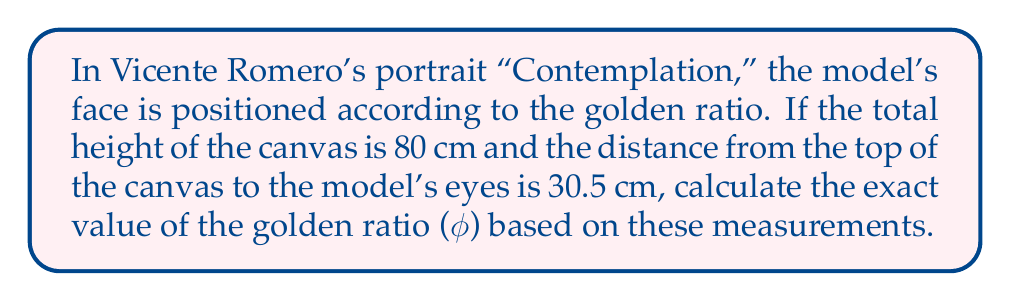Could you help me with this problem? Let's approach this step-by-step:

1) The golden ratio, φ (phi), is defined as:

   $$\phi = \frac{a+b}{a} = \frac{a}{b}$$

   where $a$ is the larger segment and $b$ is the smaller segment.

2) In this case, we have:
   - Total height (a + b) = 80 cm
   - Distance from top to eyes (b) = 30.5 cm

3) We can find $a$ by subtracting $b$ from the total height:
   $$a = 80 - 30.5 = 49.5 \text{ cm}$$

4) Now we can set up the equation:

   $$\phi = \frac{a+b}{a} = \frac{80}{49.5}$$

5) To calculate this exactly:

   $$\phi = \frac{80}{49.5} = \frac{160}{99}$$

6) This fraction is the exact value of φ based on these measurements.
Answer: $\frac{160}{99}$ 